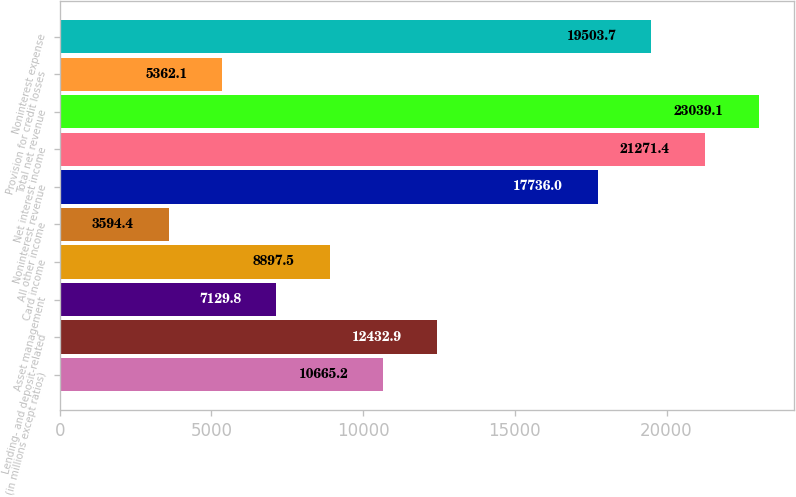Convert chart. <chart><loc_0><loc_0><loc_500><loc_500><bar_chart><fcel>(in millions except ratios)<fcel>Lending- and deposit-related<fcel>Asset management<fcel>Card income<fcel>All other income<fcel>Noninterest revenue<fcel>Net interest income<fcel>Total net revenue<fcel>Provision for credit losses<fcel>Noninterest expense<nl><fcel>10665.2<fcel>12432.9<fcel>7129.8<fcel>8897.5<fcel>3594.4<fcel>17736<fcel>21271.4<fcel>23039.1<fcel>5362.1<fcel>19503.7<nl></chart> 